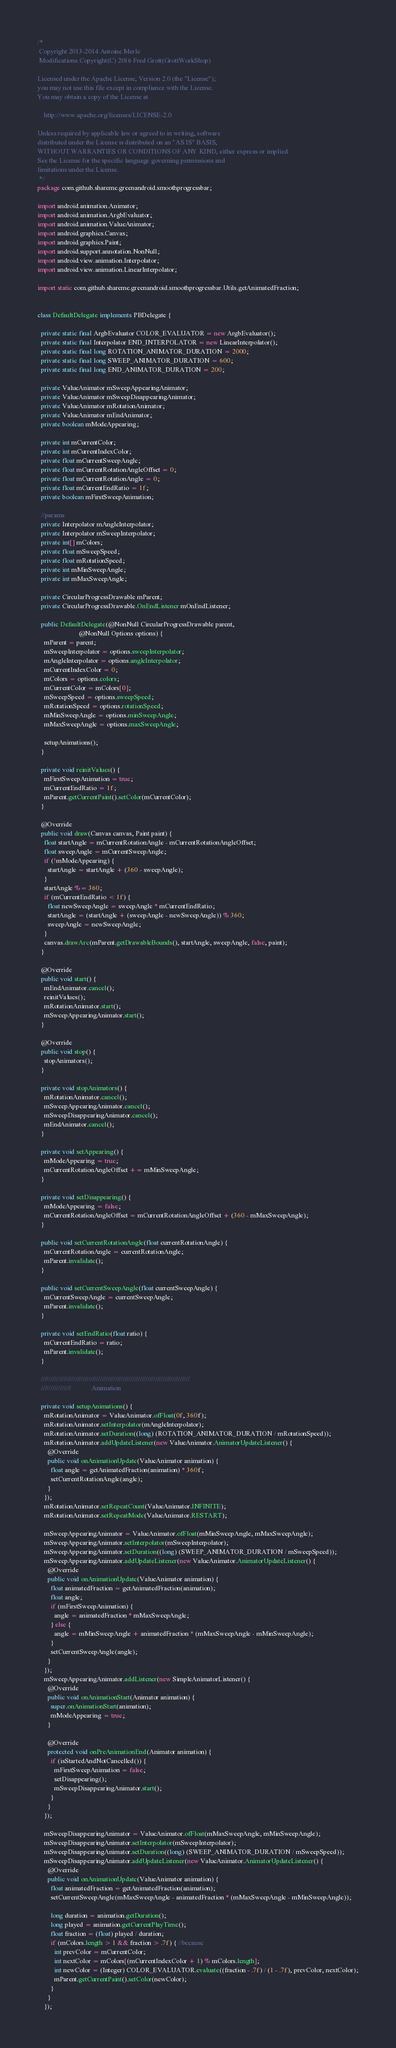Convert code to text. <code><loc_0><loc_0><loc_500><loc_500><_Java_>/*
 Copyright 2013-2014 Antoine Merle
 Modifications Copyright(C) 2016 Fred Grott(GrottWorkShop)

Licensed under the Apache License, Version 2.0 (the "License");
you may not use this file except in compliance with the License.
You may obtain a copy of the License at

    http://www.apache.org/licenses/LICENSE-2.0

Unless required by applicable law or agreed to in writing, software
distributed under the License is distributed on an "AS IS" BASIS,
WITHOUT WARRANTIES OR CONDITIONS OF ANY KIND, either express or implied.
See the License for the specific language governing permissions and
limitations under the License.
 */
package com.github.shareme.greenandroid.smoothprogressbar;

import android.animation.Animator;
import android.animation.ArgbEvaluator;
import android.animation.ValueAnimator;
import android.graphics.Canvas;
import android.graphics.Paint;
import android.support.annotation.NonNull;
import android.view.animation.Interpolator;
import android.view.animation.LinearInterpolator;

import static com.github.shareme.greenandroid.smoothprogressbar.Utils.getAnimatedFraction;


class DefaultDelegate implements PBDelegate {

  private static final ArgbEvaluator COLOR_EVALUATOR = new ArgbEvaluator();
  private static final Interpolator END_INTERPOLATOR = new LinearInterpolator();
  private static final long ROTATION_ANIMATOR_DURATION = 2000;
  private static final long SWEEP_ANIMATOR_DURATION = 600;
  private static final long END_ANIMATOR_DURATION = 200;

  private ValueAnimator mSweepAppearingAnimator;
  private ValueAnimator mSweepDisappearingAnimator;
  private ValueAnimator mRotationAnimator;
  private ValueAnimator mEndAnimator;
  private boolean mModeAppearing;

  private int mCurrentColor;
  private int mCurrentIndexColor;
  private float mCurrentSweepAngle;
  private float mCurrentRotationAngleOffset = 0;
  private float mCurrentRotationAngle = 0;
  private float mCurrentEndRatio = 1f;
  private boolean mFirstSweepAnimation;

  //params
  private Interpolator mAngleInterpolator;
  private Interpolator mSweepInterpolator;
  private int[] mColors;
  private float mSweepSpeed;
  private float mRotationSpeed;
  private int mMinSweepAngle;
  private int mMaxSweepAngle;

  private CircularProgressDrawable mParent;
  private CircularProgressDrawable.OnEndListener mOnEndListener;

  public DefaultDelegate(@NonNull CircularProgressDrawable parent,
                         @NonNull Options options) {
    mParent = parent;
    mSweepInterpolator = options.sweepInterpolator;
    mAngleInterpolator = options.angleInterpolator;
    mCurrentIndexColor = 0;
    mColors = options.colors;
    mCurrentColor = mColors[0];
    mSweepSpeed = options.sweepSpeed;
    mRotationSpeed = options.rotationSpeed;
    mMinSweepAngle = options.minSweepAngle;
    mMaxSweepAngle = options.maxSweepAngle;

    setupAnimations();
  }

  private void reinitValues() {
    mFirstSweepAnimation = true;
    mCurrentEndRatio = 1f;
    mParent.getCurrentPaint().setColor(mCurrentColor);
  }

  @Override
  public void draw(Canvas canvas, Paint paint) {
    float startAngle = mCurrentRotationAngle - mCurrentRotationAngleOffset;
    float sweepAngle = mCurrentSweepAngle;
    if (!mModeAppearing) {
      startAngle = startAngle + (360 - sweepAngle);
    }
    startAngle %= 360;
    if (mCurrentEndRatio < 1f) {
      float newSweepAngle = sweepAngle * mCurrentEndRatio;
      startAngle = (startAngle + (sweepAngle - newSweepAngle)) % 360;
      sweepAngle = newSweepAngle;
    }
    canvas.drawArc(mParent.getDrawableBounds(), startAngle, sweepAngle, false, paint);
  }

  @Override
  public void start() {
    mEndAnimator.cancel();
    reinitValues();
    mRotationAnimator.start();
    mSweepAppearingAnimator.start();
  }

  @Override
  public void stop() {
    stopAnimators();
  }

  private void stopAnimators() {
    mRotationAnimator.cancel();
    mSweepAppearingAnimator.cancel();
    mSweepDisappearingAnimator.cancel();
    mEndAnimator.cancel();
  }

  private void setAppearing() {
    mModeAppearing = true;
    mCurrentRotationAngleOffset += mMinSweepAngle;
  }

  private void setDisappearing() {
    mModeAppearing = false;
    mCurrentRotationAngleOffset = mCurrentRotationAngleOffset + (360 - mMaxSweepAngle);
  }

  public void setCurrentRotationAngle(float currentRotationAngle) {
    mCurrentRotationAngle = currentRotationAngle;
    mParent.invalidate();
  }

  public void setCurrentSweepAngle(float currentSweepAngle) {
    mCurrentSweepAngle = currentSweepAngle;
    mParent.invalidate();
  }

  private void setEndRatio(float ratio) {
    mCurrentEndRatio = ratio;
    mParent.invalidate();
  }

  //////////////////////////////////////////////////////////////////////////////
  ////////////////            Animation

  private void setupAnimations() {
    mRotationAnimator = ValueAnimator.ofFloat(0f, 360f);
    mRotationAnimator.setInterpolator(mAngleInterpolator);
    mRotationAnimator.setDuration((long) (ROTATION_ANIMATOR_DURATION / mRotationSpeed));
    mRotationAnimator.addUpdateListener(new ValueAnimator.AnimatorUpdateListener() {
      @Override
      public void onAnimationUpdate(ValueAnimator animation) {
        float angle = getAnimatedFraction(animation) * 360f;
        setCurrentRotationAngle(angle);
      }
    });
    mRotationAnimator.setRepeatCount(ValueAnimator.INFINITE);
    mRotationAnimator.setRepeatMode(ValueAnimator.RESTART);

    mSweepAppearingAnimator = ValueAnimator.ofFloat(mMinSweepAngle, mMaxSweepAngle);
    mSweepAppearingAnimator.setInterpolator(mSweepInterpolator);
    mSweepAppearingAnimator.setDuration((long) (SWEEP_ANIMATOR_DURATION / mSweepSpeed));
    mSweepAppearingAnimator.addUpdateListener(new ValueAnimator.AnimatorUpdateListener() {
      @Override
      public void onAnimationUpdate(ValueAnimator animation) {
        float animatedFraction = getAnimatedFraction(animation);
        float angle;
        if (mFirstSweepAnimation) {
          angle = animatedFraction * mMaxSweepAngle;
        } else {
          angle = mMinSweepAngle + animatedFraction * (mMaxSweepAngle - mMinSweepAngle);
        }
        setCurrentSweepAngle(angle);
      }
    });
    mSweepAppearingAnimator.addListener(new SimpleAnimatorListener() {
      @Override
      public void onAnimationStart(Animator animation) {
        super.onAnimationStart(animation);
        mModeAppearing = true;
      }

      @Override
      protected void onPreAnimationEnd(Animator animation) {
        if (isStartedAndNotCancelled()) {
          mFirstSweepAnimation = false;
          setDisappearing();
          mSweepDisappearingAnimator.start();
        }
      }
    });

    mSweepDisappearingAnimator = ValueAnimator.ofFloat(mMaxSweepAngle, mMinSweepAngle);
    mSweepDisappearingAnimator.setInterpolator(mSweepInterpolator);
    mSweepDisappearingAnimator.setDuration((long) (SWEEP_ANIMATOR_DURATION / mSweepSpeed));
    mSweepDisappearingAnimator.addUpdateListener(new ValueAnimator.AnimatorUpdateListener() {
      @Override
      public void onAnimationUpdate(ValueAnimator animation) {
        float animatedFraction = getAnimatedFraction(animation);
        setCurrentSweepAngle(mMaxSweepAngle - animatedFraction * (mMaxSweepAngle - mMinSweepAngle));

        long duration = animation.getDuration();
        long played = animation.getCurrentPlayTime();
        float fraction = (float) played / duration;
        if (mColors.length > 1 && fraction > .7f) { //because
          int prevColor = mCurrentColor;
          int nextColor = mColors[(mCurrentIndexColor + 1) % mColors.length];
          int newColor = (Integer) COLOR_EVALUATOR.evaluate((fraction - .7f) / (1 - .7f), prevColor, nextColor);
          mParent.getCurrentPaint().setColor(newColor);
        }
      }
    });</code> 